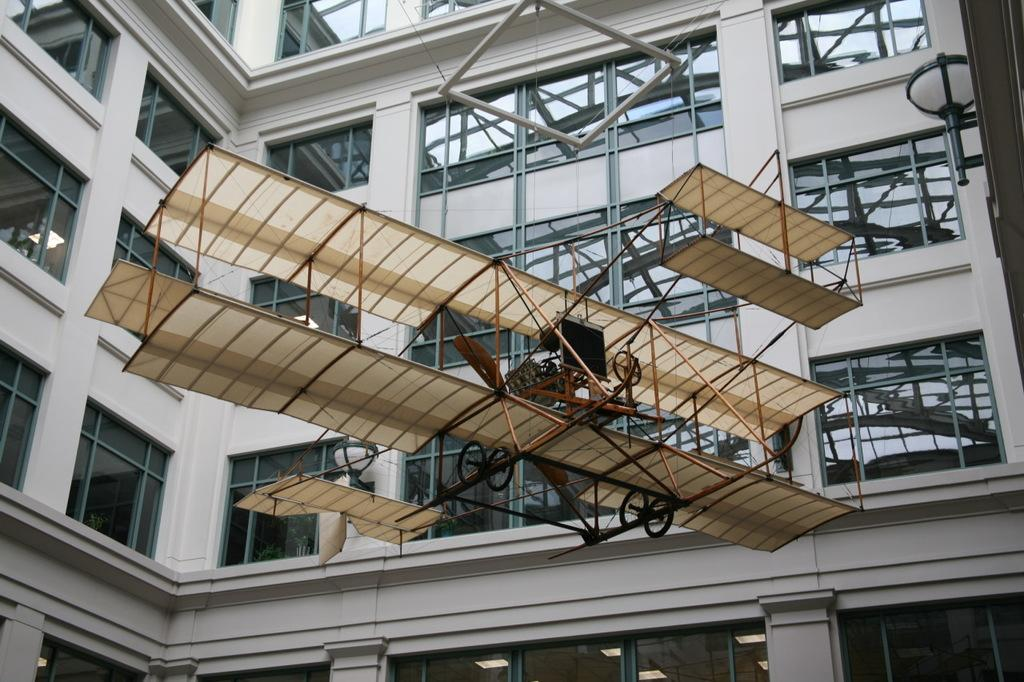What is the main subject of the image? The image shows a view of a building. What feature of the building is mentioned in the facts? The building has glass windows. What additional object is present in the image? There is a vehicle model object in the center of the image. What material is the vehicle model object made of? The vehicle model object is made with wooden sticks. What songs is the mom singing while looking at the building in the image? There is no mention of a mom or any songs in the image or the provided facts, so we cannot answer this question. 